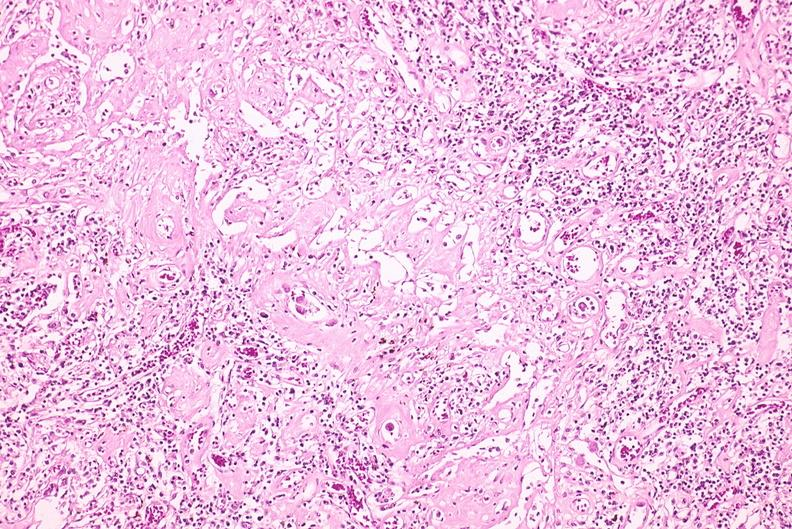does metastatic carcinoma oat cell show lymph node, cytomegalovirus?
Answer the question using a single word or phrase. No 